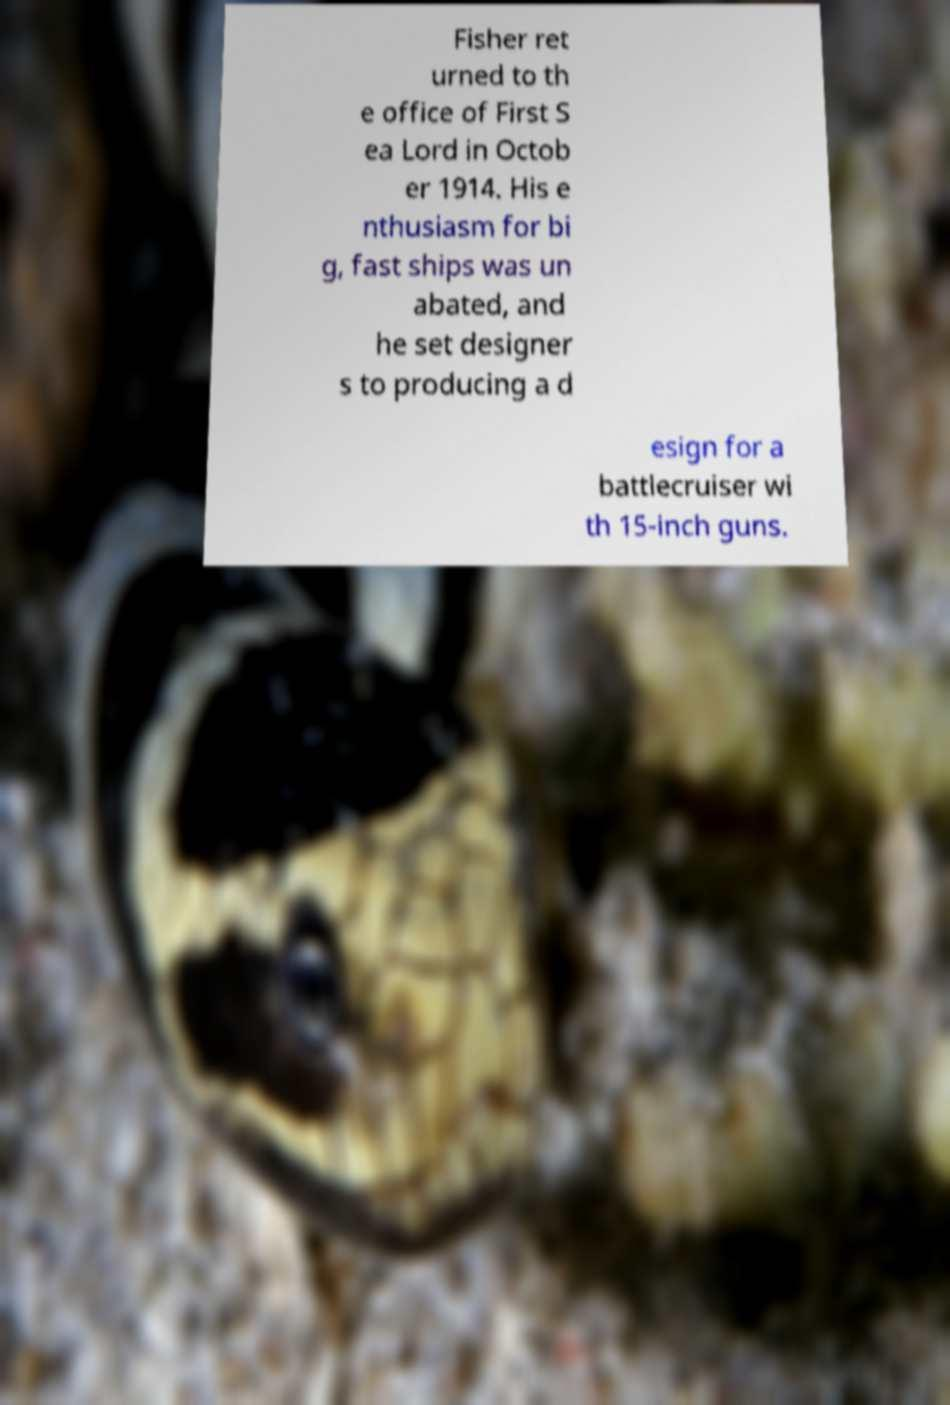For documentation purposes, I need the text within this image transcribed. Could you provide that? Fisher ret urned to th e office of First S ea Lord in Octob er 1914. His e nthusiasm for bi g, fast ships was un abated, and he set designer s to producing a d esign for a battlecruiser wi th 15-inch guns. 